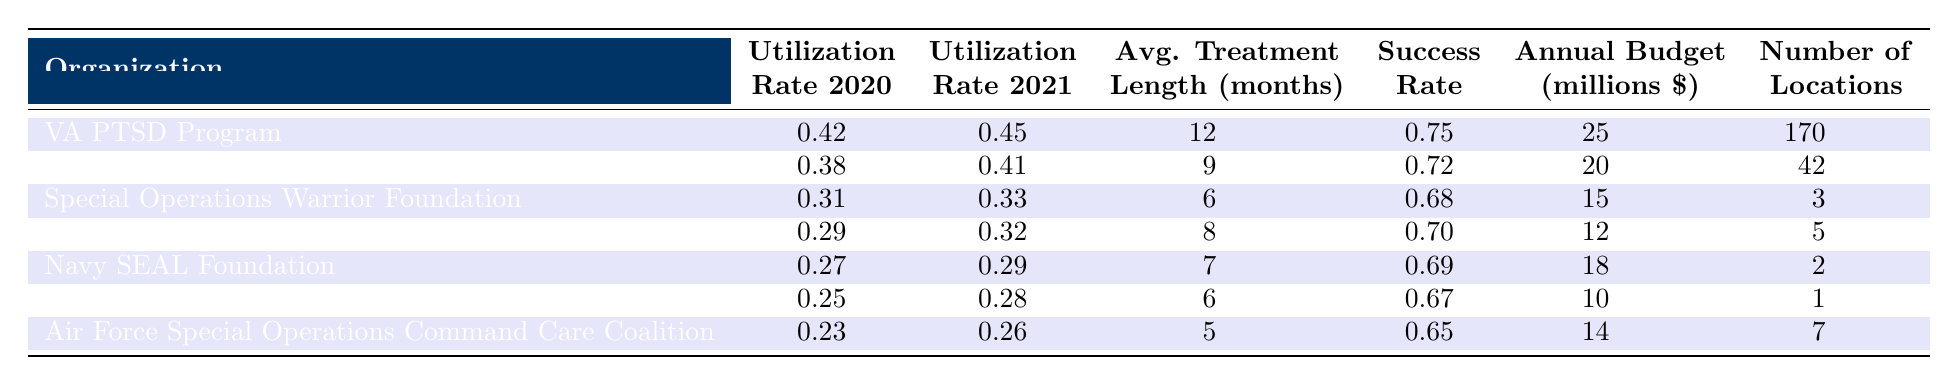What is the utilization rate of the VA PTSD Program in 2021? The VA PTSD Program has a utilization rate of 0.45 for the year 2021, as indicated in the table.
Answer: 0.45 Which organization has the highest success rate? The VA PTSD Program has the highest success rate of 0.75, as shown in the Success Rate column.
Answer: 0.75 What is the average treatment length for the Special Operations Warrior Foundation? The average length of treatment for the Special Operations Warrior Foundation is 6 months, as per the Average Length of Treatment column.
Answer: 6 What was the utilization rate increase from 2020 to 2021 for the Wounded Warrior Project? The Wounded Warrior Project had a utilization rate of 0.38 in 2020 and 0.41 in 2021. The increase is calculated as 0.41 - 0.38 = 0.03.
Answer: 0.03 Which organization's annual budget is the highest, and what is the amount? The VA PTSD Program has the highest annual budget of 25 million dollars according to the Annual Budget column.
Answer: 25 million Is the average length of treatment for the Navy SEAL Foundation greater than that of the MARSOC Foundation? The Navy SEAL Foundation has an average length of treatment of 7 months, while the MARSOC Foundation has 6 months. Since 7 is greater than 6, the statement is true.
Answer: Yes Which two organizations have the lowest utilization rates in 2021? The organizations with the lowest utilization rates in 2021 are the Air Force Special Operations Command Care Coalition with 0.26 and the MARSOC Foundation with 0.28.
Answer: Air Force Special Operations Command Care Coalition and MARSOC Foundation What is the total number of locations for all organizations combined? The total number of locations is calculated by adding them: 170 + 42 + 3 + 5 + 2 + 1 + 7 = 230.
Answer: 230 What is the difference in average treatment length between the VA PTSD Program and the Green Beret Foundation? The VA PTSD Program has an average treatment length of 12 months while the Green Beret Foundation has 8 months. The difference is 12 - 8 = 4 months.
Answer: 4 months Which organization has the lowest utilization rate in 2020? The organization with the lowest utilization rate in 2020 is the Air Force Special Operations Command Care Coalition at 0.23, as seen in the table.
Answer: 0.23 